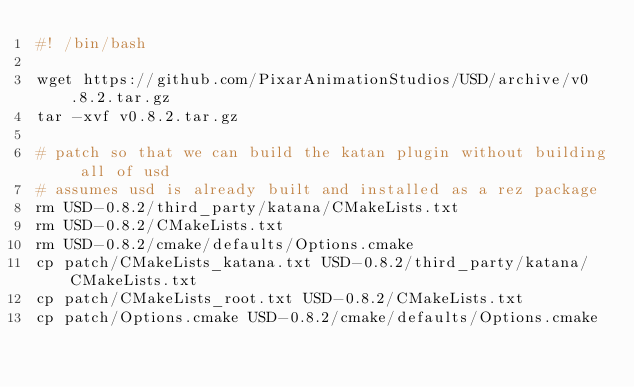<code> <loc_0><loc_0><loc_500><loc_500><_Bash_>#! /bin/bash

wget https://github.com/PixarAnimationStudios/USD/archive/v0.8.2.tar.gz
tar -xvf v0.8.2.tar.gz

# patch so that we can build the katan plugin without building all of usd
# assumes usd is already built and installed as a rez package
rm USD-0.8.2/third_party/katana/CMakeLists.txt
rm USD-0.8.2/CMakeLists.txt
rm USD-0.8.2/cmake/defaults/Options.cmake
cp patch/CMakeLists_katana.txt USD-0.8.2/third_party/katana/CMakeLists.txt
cp patch/CMakeLists_root.txt USD-0.8.2/CMakeLists.txt
cp patch/Options.cmake USD-0.8.2/cmake/defaults/Options.cmake
</code> 